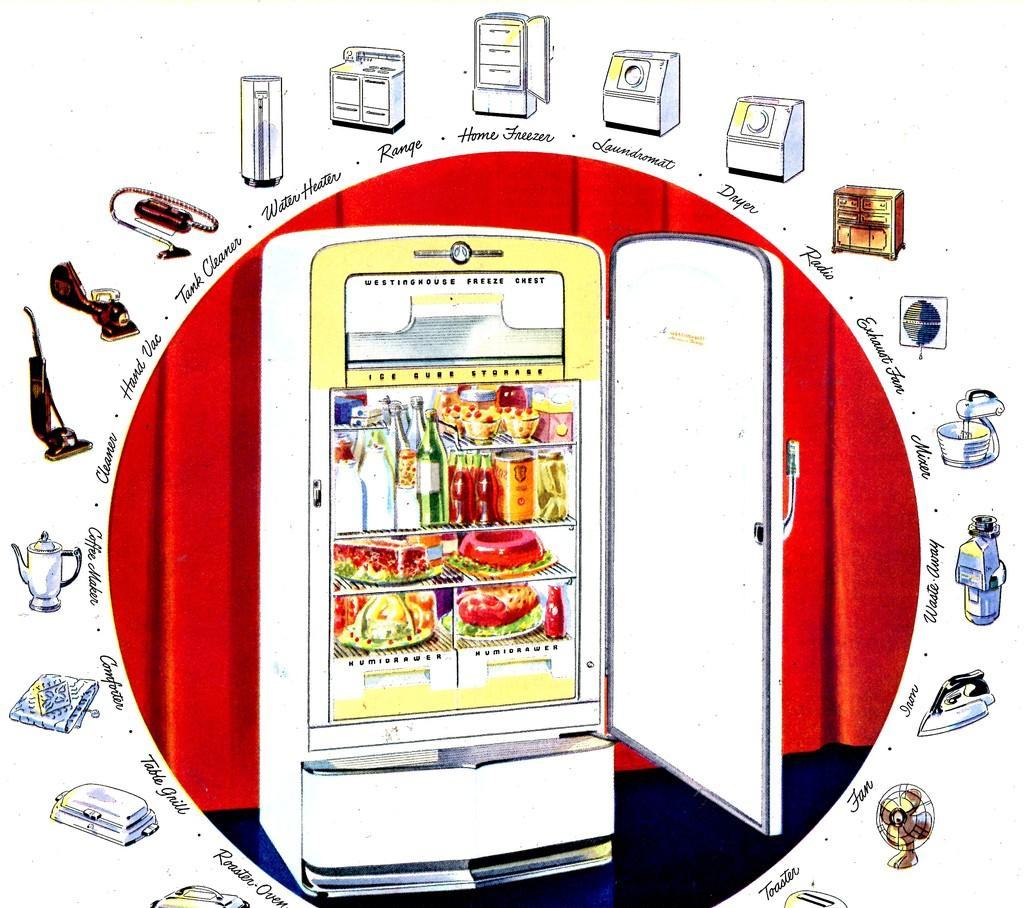<image>
Render a clear and concise summary of the photo. A picture of a Westinghouse Freeze Chest shows a freezer full of food. 